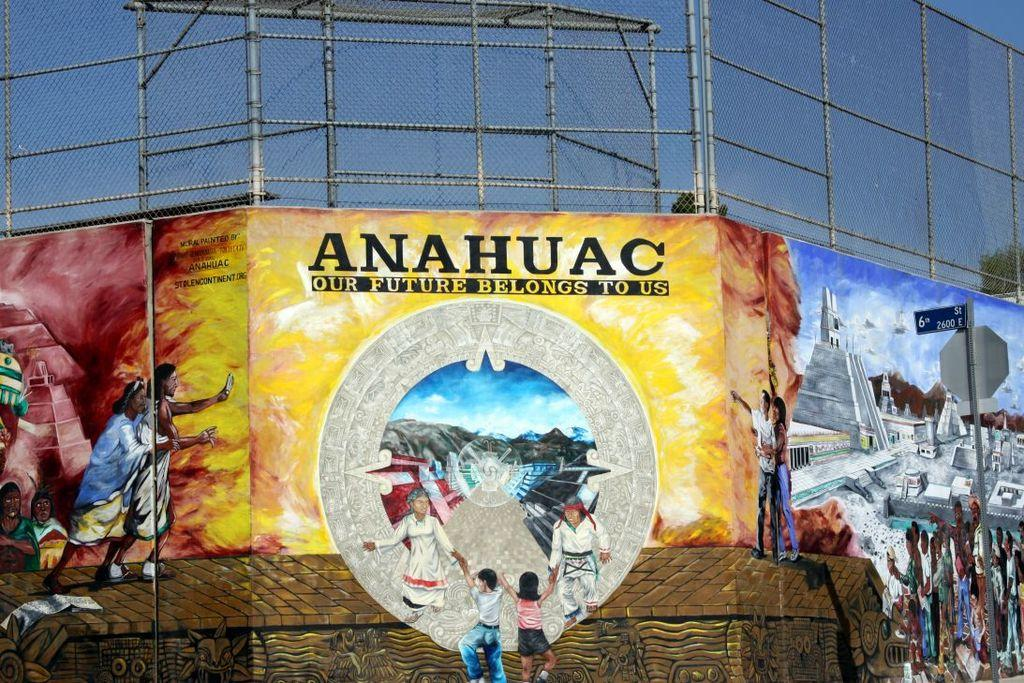<image>
Create a compact narrative representing the image presented. A large yellow banner that says Our Future Belongs To Us. 